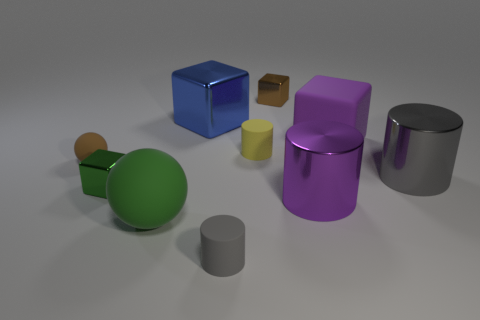Subtract all cubes. How many objects are left? 6 Add 7 blue blocks. How many blue blocks are left? 8 Add 4 small cyan rubber cylinders. How many small cyan rubber cylinders exist? 4 Subtract 0 cyan balls. How many objects are left? 10 Subtract all big purple spheres. Subtract all gray cylinders. How many objects are left? 8 